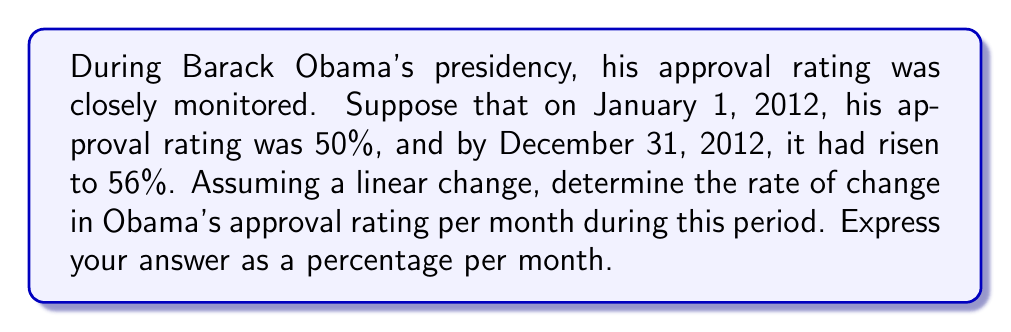Help me with this question. To solve this problem, we'll use the concept of linear equations and rate of change. Let's break it down step-by-step:

1) First, let's identify our variables:
   $x$ = time in months
   $y$ = approval rating in percentage

2) We know two points:
   $(x_1, y_1) = (0, 50)$ (January 1, 2012)
   $(x_2, y_2) = (12, 56)$ (December 31, 2012)

3) The rate of change (slope) formula is:

   $$m = \frac{y_2 - y_1}{x_2 - x_1}$$

4) Let's plug in our values:

   $$m = \frac{56 - 50}{12 - 0} = \frac{6}{12}$$

5) Simplify:

   $$m = \frac{1}{2} = 0.5$$

6) This means the approval rating increased by 0.5 percentage points per month.

7) To express this as a percentage per month, we multiply by 100:

   $$0.5 \times 100 = 50\%$$

Therefore, the rate of change in Obama's approval rating was 0.5% per month.
Answer: 0.5% per month 